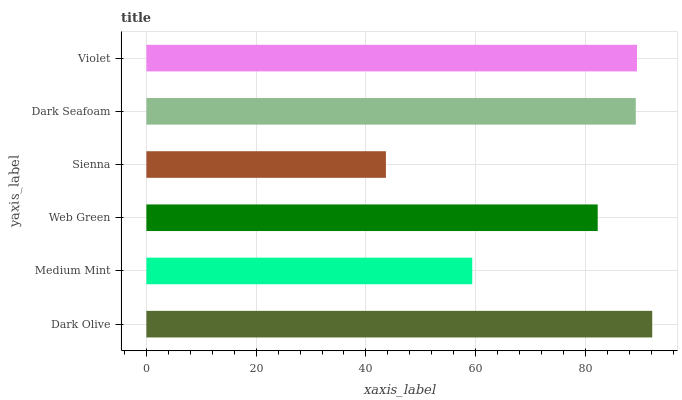Is Sienna the minimum?
Answer yes or no. Yes. Is Dark Olive the maximum?
Answer yes or no. Yes. Is Medium Mint the minimum?
Answer yes or no. No. Is Medium Mint the maximum?
Answer yes or no. No. Is Dark Olive greater than Medium Mint?
Answer yes or no. Yes. Is Medium Mint less than Dark Olive?
Answer yes or no. Yes. Is Medium Mint greater than Dark Olive?
Answer yes or no. No. Is Dark Olive less than Medium Mint?
Answer yes or no. No. Is Dark Seafoam the high median?
Answer yes or no. Yes. Is Web Green the low median?
Answer yes or no. Yes. Is Violet the high median?
Answer yes or no. No. Is Medium Mint the low median?
Answer yes or no. No. 